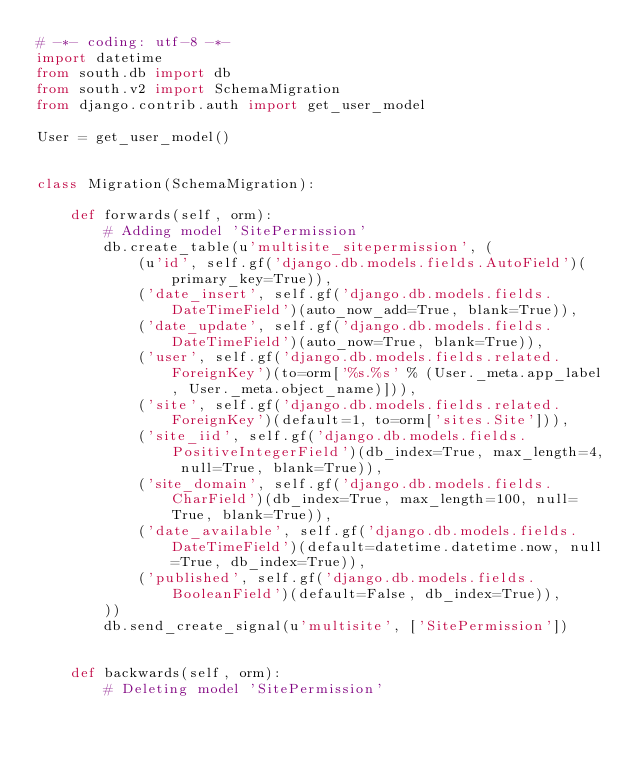<code> <loc_0><loc_0><loc_500><loc_500><_Python_># -*- coding: utf-8 -*-
import datetime
from south.db import db
from south.v2 import SchemaMigration
from django.contrib.auth import get_user_model

User = get_user_model()


class Migration(SchemaMigration):

    def forwards(self, orm):
        # Adding model 'SitePermission'
        db.create_table(u'multisite_sitepermission', (
            (u'id', self.gf('django.db.models.fields.AutoField')(primary_key=True)),
            ('date_insert', self.gf('django.db.models.fields.DateTimeField')(auto_now_add=True, blank=True)),
            ('date_update', self.gf('django.db.models.fields.DateTimeField')(auto_now=True, blank=True)),
            ('user', self.gf('django.db.models.fields.related.ForeignKey')(to=orm['%s.%s' % (User._meta.app_label, User._meta.object_name)])),
            ('site', self.gf('django.db.models.fields.related.ForeignKey')(default=1, to=orm['sites.Site'])),
            ('site_iid', self.gf('django.db.models.fields.PositiveIntegerField')(db_index=True, max_length=4, null=True, blank=True)),
            ('site_domain', self.gf('django.db.models.fields.CharField')(db_index=True, max_length=100, null=True, blank=True)),
            ('date_available', self.gf('django.db.models.fields.DateTimeField')(default=datetime.datetime.now, null=True, db_index=True)),
            ('published', self.gf('django.db.models.fields.BooleanField')(default=False, db_index=True)),
        ))
        db.send_create_signal(u'multisite', ['SitePermission'])


    def backwards(self, orm):
        # Deleting model 'SitePermission'</code> 